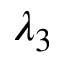<formula> <loc_0><loc_0><loc_500><loc_500>\lambda _ { 3 }</formula> 